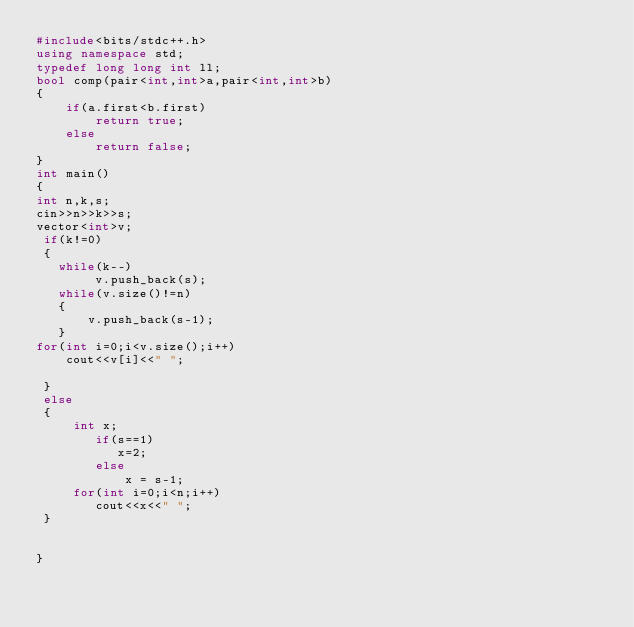Convert code to text. <code><loc_0><loc_0><loc_500><loc_500><_C++_>#include<bits/stdc++.h>
using namespace std;
typedef long long int ll;
bool comp(pair<int,int>a,pair<int,int>b)
{
    if(a.first<b.first)
        return true;
    else
        return false;
}
int main()
{
int n,k,s;
cin>>n>>k>>s;
vector<int>v;
 if(k!=0)
 {
   while(k--)
        v.push_back(s);
   while(v.size()!=n)
   {
       v.push_back(s-1);
   }
for(int i=0;i<v.size();i++)
    cout<<v[i]<<" ";

 }
 else
 {
     int x;
        if(s==1)
           x=2;
        else
            x = s-1;
     for(int i=0;i<n;i++)
        cout<<x<<" ";
 }


}

</code> 